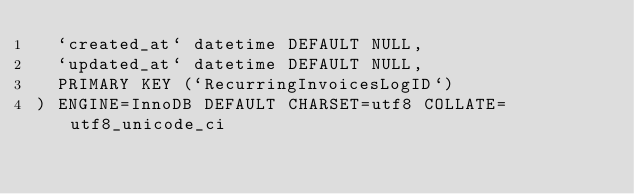<code> <loc_0><loc_0><loc_500><loc_500><_SQL_>  `created_at` datetime DEFAULT NULL,
  `updated_at` datetime DEFAULT NULL,
  PRIMARY KEY (`RecurringInvoicesLogID`)
) ENGINE=InnoDB DEFAULT CHARSET=utf8 COLLATE=utf8_unicode_ci</code> 